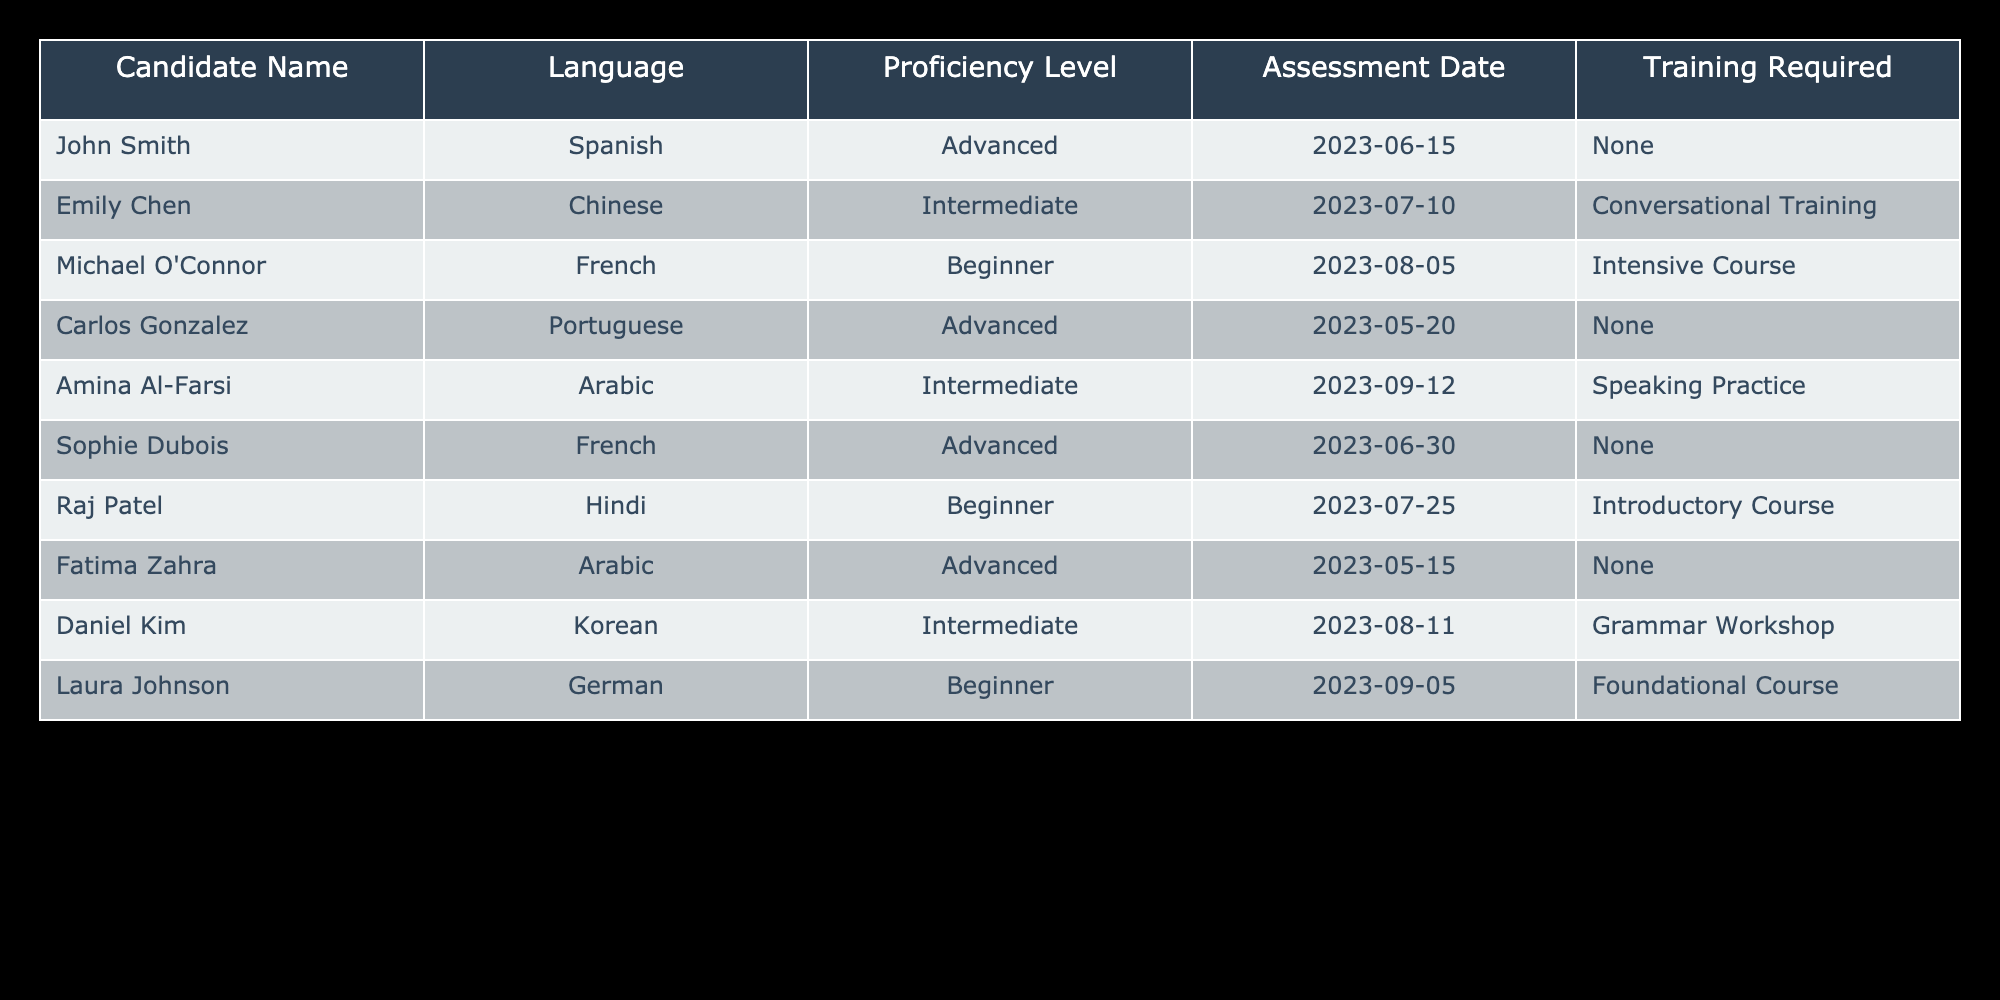What are the proficiency levels of candidates who require training? From the table, we can see the candidates who require training: Emily Chen (Intermediate), Michael O'Connor (Beginner), Amina Al-Farsi (Intermediate), Raj Patel (Beginner), and Laura Johnson (Beginner). The proficiency levels of these candidates are Intermediate and Beginner.
Answer: Intermediate and Beginner How many candidates assessed have an Advanced language proficiency? By counting the rows where the Proficiency Level is marked as Advanced, we find that 4 candidates have this proficiency level: John Smith, Carlos Gonzalez, Sophie Dubois, and Fatima Zahra. Therefore, the total number is 4.
Answer: 4 Is there a candidate who has both Advanced proficiency and requires no training? Looking through the table, we find candidates labeled as Advanced: John Smith, Carlos Gonzalez, Sophie Dubois, and Fatima Zahra. Among these, John Smith, Carlos Gonzalez, and Sophie Dubois require no training. Therefore, the answer is yes.
Answer: Yes What is the average proficiency level across all candidates, assigning values of 3 for Advanced, 2 for Intermediate, and 1 for Beginner? First, we assign numerical values to the proficiency levels: 3 for Advanced, 2 for Intermediate, and 1 for Beginner. Then, we sum the values: John Smith (3) + Emily Chen (2) + Michael O'Connor (1) + Carlos Gonzalez (3) + Amina Al-Farsi (2) + Sophie Dubois (3) + Raj Patel (1) + Fatima Zahra (3) + Daniel Kim (2) + Laura Johnson (1) = 20. There are 10 candidates, so the average is 20/10 = 2.
Answer: 2 Which language has the highest number of candidates requiring training? We need to count the candidates requiring training for each language: Spanish (0), Chinese (1), French (1), Portuguese (0), Arabic (1), Hindi (1), Korean (1), German (1). Chinese has the highest count with 1 candidate requiring training, as do some other languages, but no language has more than 1 candidate requiring training.
Answer: None (1 each) 